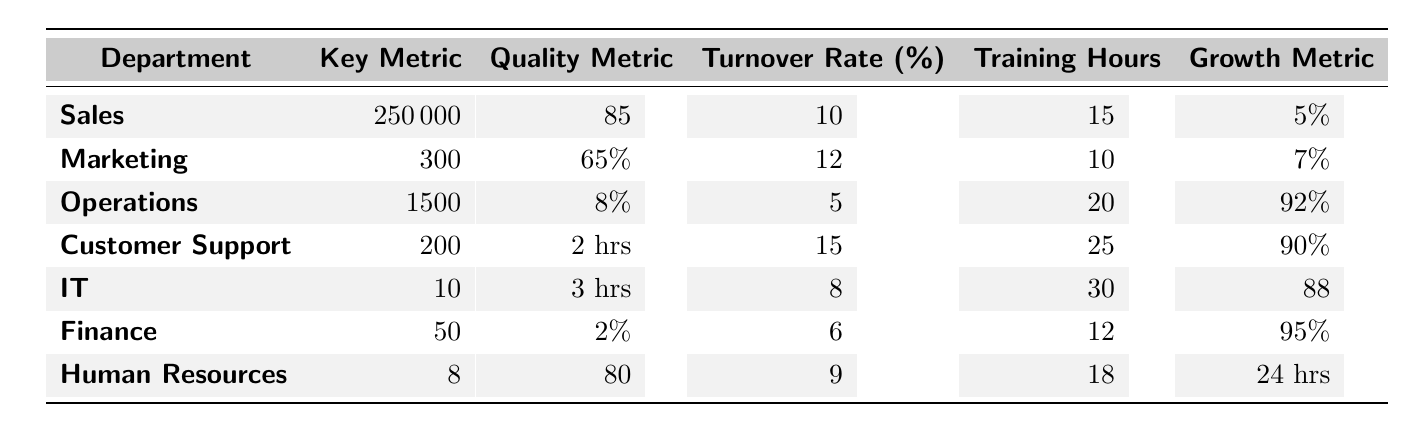What is the Employee Turnover Rate for the Operations department? The table lists the Employee Turnover Rate for the Operations department, which shows a value of 5%.
Answer: 5% Which department has the highest Customer Satisfaction Score? The Customer Satisfaction Score of each department is compared, with Sales having the highest at 85.
Answer: Sales What is the average Training Hours per Employee across all departments? The total Training Hours for all departments is 15 + 10 + 20 + 25 + 30 + 12 + 18 = 130. There are 7 departments, so average is 130/7 ≈ 18.57.
Answer: 18.57 What department has a lower Employee Turnover Rate than IT? IT has an Employee Turnover Rate of 8%. All departments are analyzed. Operations (5%) and Finance (6%) have lower rates.
Answer: Operations and Finance What is the highest value of Monthly Sales Growth among all departments? Analyzing the Growth Metrics: Sales has 5%, Marketing has 7%, Operations has 92%, Customer Support has 90%, IT has 88%, Finance has 95%, and Human Resources has 24 hrs. The highest among these is 95% from Finance.
Answer: 95% Is the Error Rate Percentage for Finance lower than the Employee Turnover Rate for Customer Support? Finance has an Error Rate Percentage of 2%, while Customer Support has an Employee Turnover Rate of 15%. Comparing these values shows that 2% is indeed lower than 15%.
Answer: Yes Which department resolves the most tickets per employee? The table indicates that the Customer Support department resolves 200 tickets per employee, more than any other department listed.
Answer: Customer Support What is the total Units Produced per Employee for Sales and Marketing combined? Sales does not have a Units Produced metric, but if it were to be considered, only the Operations department has this metric with a value of 1500. The Calculation should be regarded as zero for Sales, hence the total is 1500.
Answer: 1500 Is the average response time for Customer Support less than 3 hours? The Average Response Time for Customer Support is listed as 2 hours, which is indeed less than 3 hours.
Answer: Yes If we consider average values for key metrics in similar departments, how would you classify Sales and Marketing? Sales has an Average Sales of 250000 and Marketing has Leads of 300. While both are successful, on a surface level Sales shows higher financial output than Marketing does in lead generation, revealing a potential operational efficiency difference.
Answer: Sales is more financially efficient than Marketing 